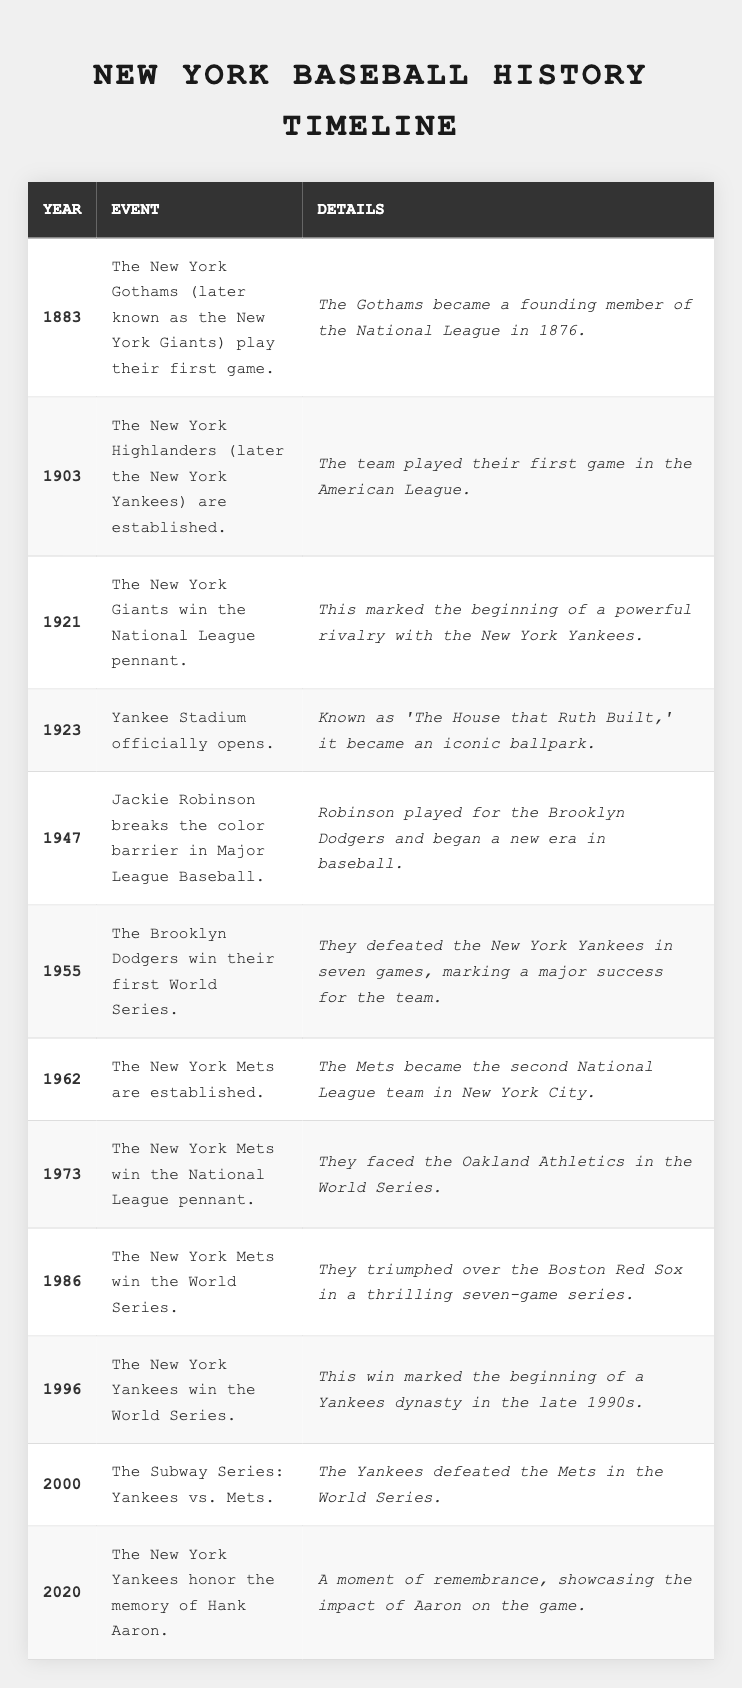What year did Jackie Robinson break the color barrier in Major League Baseball? The table shows that Jackie Robinson broke the color barrier in 1947.
Answer: 1947 Which team won the World Series in 1986? The event corresponding to the year 1986 states that the New York Mets won the World Series.
Answer: New York Mets How many significant events in New York baseball history are recorded in the table? By counting the entries in the table, it shows a total of 12 significant events.
Answer: 12 What was the first event listed in the table? The first entry shows that the New York Gothams played their first game in 1883.
Answer: The New York Gothams played their first game Did the New York Giants ever win the National League pennant? The table indicates that the New York Giants won the National League pennant in 1921.
Answer: Yes What is the time gap between the establishment of the New York Highlanders and the opening of Yankee Stadium? The Highlanders were established in 1903 and Yankee Stadium opened in 1923. The time gap is 20 years.
Answer: 20 years How many years passed between the Brooklyn Dodgers' first World Series win and the New York Mets' establishment? The Dodgers won their first World Series in 1955, and the Mets were established in 1962. The difference is 7 years.
Answer: 7 years What were the two teams involved in the Subway Series held in the year 2000? The table shows that the Subway Series in 2000 was between the Yankees and the Mets.
Answer: Yankees and Mets Which event happened immediately before the opening of Yankee Stadium? The event before Yankee Stadium opening refers to winning the National League pennant, which happened in 1921.
Answer: The New York Giants winning the National League pennant How many World Series victories did the New York Yankees have listed in the table? The table lists the Yankees winning the World Series in 1996 and again in the Subway Series in 2000, which is a total of 2 victories.
Answer: 2 victories 